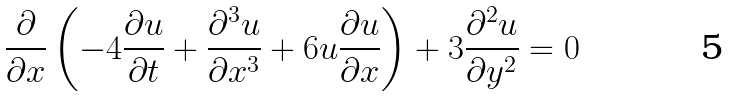Convert formula to latex. <formula><loc_0><loc_0><loc_500><loc_500>\frac { \partial } { \partial x } \left ( - 4 \frac { \partial u } { \partial t } + \frac { \partial ^ { 3 } u } { \partial x ^ { 3 } } + 6 u \frac { \partial u } { \partial x } \right ) + 3 \frac { \partial ^ { 2 } u } { \partial y ^ { 2 } } = 0 \,</formula> 